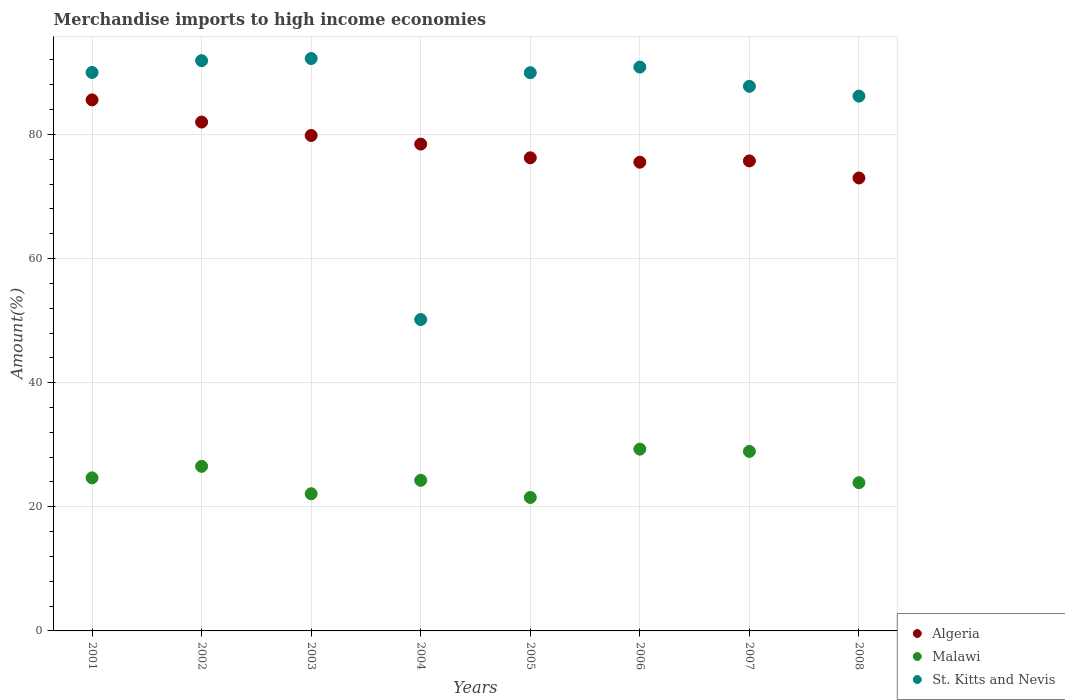Is the number of dotlines equal to the number of legend labels?
Offer a terse response. Yes. What is the percentage of amount earned from merchandise imports in Malawi in 2005?
Keep it short and to the point. 21.5. Across all years, what is the maximum percentage of amount earned from merchandise imports in Algeria?
Offer a terse response. 85.56. Across all years, what is the minimum percentage of amount earned from merchandise imports in Malawi?
Provide a short and direct response. 21.5. In which year was the percentage of amount earned from merchandise imports in Algeria maximum?
Keep it short and to the point. 2001. What is the total percentage of amount earned from merchandise imports in Algeria in the graph?
Your answer should be compact. 626.27. What is the difference between the percentage of amount earned from merchandise imports in Malawi in 2003 and that in 2007?
Your answer should be very brief. -6.82. What is the difference between the percentage of amount earned from merchandise imports in Malawi in 2006 and the percentage of amount earned from merchandise imports in Algeria in 2003?
Keep it short and to the point. -50.54. What is the average percentage of amount earned from merchandise imports in Algeria per year?
Your answer should be very brief. 78.28. In the year 2007, what is the difference between the percentage of amount earned from merchandise imports in Algeria and percentage of amount earned from merchandise imports in St. Kitts and Nevis?
Provide a succinct answer. -12.02. What is the ratio of the percentage of amount earned from merchandise imports in Algeria in 2003 to that in 2006?
Provide a succinct answer. 1.06. Is the percentage of amount earned from merchandise imports in St. Kitts and Nevis in 2006 less than that in 2008?
Your answer should be very brief. No. What is the difference between the highest and the second highest percentage of amount earned from merchandise imports in St. Kitts and Nevis?
Provide a succinct answer. 0.35. What is the difference between the highest and the lowest percentage of amount earned from merchandise imports in Malawi?
Keep it short and to the point. 7.79. In how many years, is the percentage of amount earned from merchandise imports in St. Kitts and Nevis greater than the average percentage of amount earned from merchandise imports in St. Kitts and Nevis taken over all years?
Offer a very short reply. 7. Is the sum of the percentage of amount earned from merchandise imports in St. Kitts and Nevis in 2004 and 2007 greater than the maximum percentage of amount earned from merchandise imports in Malawi across all years?
Make the answer very short. Yes. Is the percentage of amount earned from merchandise imports in Algeria strictly greater than the percentage of amount earned from merchandise imports in Malawi over the years?
Ensure brevity in your answer.  Yes. How many dotlines are there?
Keep it short and to the point. 3. What is the difference between two consecutive major ticks on the Y-axis?
Ensure brevity in your answer.  20. How many legend labels are there?
Provide a succinct answer. 3. How are the legend labels stacked?
Your answer should be very brief. Vertical. What is the title of the graph?
Give a very brief answer. Merchandise imports to high income economies. Does "Bangladesh" appear as one of the legend labels in the graph?
Provide a succinct answer. No. What is the label or title of the Y-axis?
Ensure brevity in your answer.  Amount(%). What is the Amount(%) of Algeria in 2001?
Your response must be concise. 85.56. What is the Amount(%) in Malawi in 2001?
Your answer should be very brief. 24.66. What is the Amount(%) in St. Kitts and Nevis in 2001?
Ensure brevity in your answer.  89.98. What is the Amount(%) of Algeria in 2002?
Your answer should be compact. 81.99. What is the Amount(%) in Malawi in 2002?
Provide a succinct answer. 26.52. What is the Amount(%) of St. Kitts and Nevis in 2002?
Provide a short and direct response. 91.88. What is the Amount(%) in Algeria in 2003?
Keep it short and to the point. 79.83. What is the Amount(%) in Malawi in 2003?
Keep it short and to the point. 22.1. What is the Amount(%) in St. Kitts and Nevis in 2003?
Your response must be concise. 92.23. What is the Amount(%) in Algeria in 2004?
Make the answer very short. 78.44. What is the Amount(%) in Malawi in 2004?
Offer a very short reply. 24.27. What is the Amount(%) in St. Kitts and Nevis in 2004?
Give a very brief answer. 50.17. What is the Amount(%) of Algeria in 2005?
Give a very brief answer. 76.23. What is the Amount(%) in Malawi in 2005?
Offer a very short reply. 21.5. What is the Amount(%) in St. Kitts and Nevis in 2005?
Keep it short and to the point. 89.94. What is the Amount(%) of Algeria in 2006?
Offer a very short reply. 75.52. What is the Amount(%) of Malawi in 2006?
Provide a succinct answer. 29.29. What is the Amount(%) in St. Kitts and Nevis in 2006?
Provide a short and direct response. 90.85. What is the Amount(%) of Algeria in 2007?
Provide a short and direct response. 75.73. What is the Amount(%) in Malawi in 2007?
Your answer should be very brief. 28.93. What is the Amount(%) of St. Kitts and Nevis in 2007?
Keep it short and to the point. 87.75. What is the Amount(%) in Algeria in 2008?
Your response must be concise. 72.98. What is the Amount(%) in Malawi in 2008?
Offer a terse response. 23.88. What is the Amount(%) in St. Kitts and Nevis in 2008?
Make the answer very short. 86.17. Across all years, what is the maximum Amount(%) in Algeria?
Offer a terse response. 85.56. Across all years, what is the maximum Amount(%) in Malawi?
Provide a short and direct response. 29.29. Across all years, what is the maximum Amount(%) in St. Kitts and Nevis?
Provide a short and direct response. 92.23. Across all years, what is the minimum Amount(%) of Algeria?
Your answer should be very brief. 72.98. Across all years, what is the minimum Amount(%) in Malawi?
Ensure brevity in your answer.  21.5. Across all years, what is the minimum Amount(%) in St. Kitts and Nevis?
Ensure brevity in your answer.  50.17. What is the total Amount(%) of Algeria in the graph?
Give a very brief answer. 626.27. What is the total Amount(%) of Malawi in the graph?
Make the answer very short. 201.15. What is the total Amount(%) in St. Kitts and Nevis in the graph?
Your answer should be compact. 678.95. What is the difference between the Amount(%) in Algeria in 2001 and that in 2002?
Give a very brief answer. 3.57. What is the difference between the Amount(%) of Malawi in 2001 and that in 2002?
Provide a short and direct response. -1.86. What is the difference between the Amount(%) of St. Kitts and Nevis in 2001 and that in 2002?
Keep it short and to the point. -1.9. What is the difference between the Amount(%) of Algeria in 2001 and that in 2003?
Your response must be concise. 5.73. What is the difference between the Amount(%) in Malawi in 2001 and that in 2003?
Your answer should be compact. 2.56. What is the difference between the Amount(%) of St. Kitts and Nevis in 2001 and that in 2003?
Provide a short and direct response. -2.25. What is the difference between the Amount(%) of Algeria in 2001 and that in 2004?
Give a very brief answer. 7.12. What is the difference between the Amount(%) in Malawi in 2001 and that in 2004?
Offer a terse response. 0.4. What is the difference between the Amount(%) of St. Kitts and Nevis in 2001 and that in 2004?
Your answer should be compact. 39.81. What is the difference between the Amount(%) of Algeria in 2001 and that in 2005?
Provide a short and direct response. 9.33. What is the difference between the Amount(%) in Malawi in 2001 and that in 2005?
Ensure brevity in your answer.  3.16. What is the difference between the Amount(%) in St. Kitts and Nevis in 2001 and that in 2005?
Offer a terse response. 0.04. What is the difference between the Amount(%) of Algeria in 2001 and that in 2006?
Ensure brevity in your answer.  10.04. What is the difference between the Amount(%) in Malawi in 2001 and that in 2006?
Your response must be concise. -4.63. What is the difference between the Amount(%) in St. Kitts and Nevis in 2001 and that in 2006?
Provide a succinct answer. -0.87. What is the difference between the Amount(%) in Algeria in 2001 and that in 2007?
Give a very brief answer. 9.83. What is the difference between the Amount(%) in Malawi in 2001 and that in 2007?
Provide a succinct answer. -4.27. What is the difference between the Amount(%) in St. Kitts and Nevis in 2001 and that in 2007?
Provide a succinct answer. 2.23. What is the difference between the Amount(%) in Algeria in 2001 and that in 2008?
Ensure brevity in your answer.  12.58. What is the difference between the Amount(%) of Malawi in 2001 and that in 2008?
Make the answer very short. 0.78. What is the difference between the Amount(%) in St. Kitts and Nevis in 2001 and that in 2008?
Make the answer very short. 3.81. What is the difference between the Amount(%) in Algeria in 2002 and that in 2003?
Your answer should be very brief. 2.16. What is the difference between the Amount(%) of Malawi in 2002 and that in 2003?
Your response must be concise. 4.41. What is the difference between the Amount(%) of St. Kitts and Nevis in 2002 and that in 2003?
Offer a terse response. -0.35. What is the difference between the Amount(%) in Algeria in 2002 and that in 2004?
Give a very brief answer. 3.55. What is the difference between the Amount(%) in Malawi in 2002 and that in 2004?
Offer a very short reply. 2.25. What is the difference between the Amount(%) in St. Kitts and Nevis in 2002 and that in 2004?
Keep it short and to the point. 41.71. What is the difference between the Amount(%) in Algeria in 2002 and that in 2005?
Your answer should be compact. 5.76. What is the difference between the Amount(%) in Malawi in 2002 and that in 2005?
Your response must be concise. 5.02. What is the difference between the Amount(%) of St. Kitts and Nevis in 2002 and that in 2005?
Ensure brevity in your answer.  1.94. What is the difference between the Amount(%) of Algeria in 2002 and that in 2006?
Provide a succinct answer. 6.47. What is the difference between the Amount(%) of Malawi in 2002 and that in 2006?
Offer a terse response. -2.77. What is the difference between the Amount(%) of Algeria in 2002 and that in 2007?
Provide a succinct answer. 6.26. What is the difference between the Amount(%) in Malawi in 2002 and that in 2007?
Keep it short and to the point. -2.41. What is the difference between the Amount(%) of St. Kitts and Nevis in 2002 and that in 2007?
Your answer should be very brief. 4.13. What is the difference between the Amount(%) of Algeria in 2002 and that in 2008?
Your answer should be compact. 9.01. What is the difference between the Amount(%) of Malawi in 2002 and that in 2008?
Provide a succinct answer. 2.63. What is the difference between the Amount(%) of St. Kitts and Nevis in 2002 and that in 2008?
Ensure brevity in your answer.  5.71. What is the difference between the Amount(%) in Algeria in 2003 and that in 2004?
Give a very brief answer. 1.39. What is the difference between the Amount(%) in Malawi in 2003 and that in 2004?
Make the answer very short. -2.16. What is the difference between the Amount(%) of St. Kitts and Nevis in 2003 and that in 2004?
Offer a very short reply. 42.06. What is the difference between the Amount(%) in Algeria in 2003 and that in 2005?
Your answer should be very brief. 3.6. What is the difference between the Amount(%) in Malawi in 2003 and that in 2005?
Ensure brevity in your answer.  0.6. What is the difference between the Amount(%) of St. Kitts and Nevis in 2003 and that in 2005?
Provide a succinct answer. 2.29. What is the difference between the Amount(%) in Algeria in 2003 and that in 2006?
Provide a succinct answer. 4.31. What is the difference between the Amount(%) of Malawi in 2003 and that in 2006?
Keep it short and to the point. -7.19. What is the difference between the Amount(%) in St. Kitts and Nevis in 2003 and that in 2006?
Your response must be concise. 1.38. What is the difference between the Amount(%) of Algeria in 2003 and that in 2007?
Provide a succinct answer. 4.1. What is the difference between the Amount(%) in Malawi in 2003 and that in 2007?
Your answer should be very brief. -6.82. What is the difference between the Amount(%) of St. Kitts and Nevis in 2003 and that in 2007?
Offer a terse response. 4.48. What is the difference between the Amount(%) in Algeria in 2003 and that in 2008?
Your answer should be very brief. 6.85. What is the difference between the Amount(%) in Malawi in 2003 and that in 2008?
Provide a succinct answer. -1.78. What is the difference between the Amount(%) in St. Kitts and Nevis in 2003 and that in 2008?
Provide a short and direct response. 6.06. What is the difference between the Amount(%) in Algeria in 2004 and that in 2005?
Provide a succinct answer. 2.21. What is the difference between the Amount(%) of Malawi in 2004 and that in 2005?
Offer a very short reply. 2.77. What is the difference between the Amount(%) of St. Kitts and Nevis in 2004 and that in 2005?
Ensure brevity in your answer.  -39.77. What is the difference between the Amount(%) of Algeria in 2004 and that in 2006?
Your answer should be compact. 2.91. What is the difference between the Amount(%) in Malawi in 2004 and that in 2006?
Your answer should be very brief. -5.02. What is the difference between the Amount(%) in St. Kitts and Nevis in 2004 and that in 2006?
Your answer should be very brief. -40.68. What is the difference between the Amount(%) of Algeria in 2004 and that in 2007?
Your response must be concise. 2.71. What is the difference between the Amount(%) in Malawi in 2004 and that in 2007?
Provide a succinct answer. -4.66. What is the difference between the Amount(%) of St. Kitts and Nevis in 2004 and that in 2007?
Make the answer very short. -37.58. What is the difference between the Amount(%) of Algeria in 2004 and that in 2008?
Your answer should be compact. 5.46. What is the difference between the Amount(%) in Malawi in 2004 and that in 2008?
Offer a terse response. 0.38. What is the difference between the Amount(%) in St. Kitts and Nevis in 2004 and that in 2008?
Ensure brevity in your answer.  -36. What is the difference between the Amount(%) of Algeria in 2005 and that in 2006?
Keep it short and to the point. 0.71. What is the difference between the Amount(%) in Malawi in 2005 and that in 2006?
Provide a short and direct response. -7.79. What is the difference between the Amount(%) of St. Kitts and Nevis in 2005 and that in 2006?
Provide a succinct answer. -0.91. What is the difference between the Amount(%) of Algeria in 2005 and that in 2007?
Offer a very short reply. 0.5. What is the difference between the Amount(%) of Malawi in 2005 and that in 2007?
Your answer should be very brief. -7.43. What is the difference between the Amount(%) in St. Kitts and Nevis in 2005 and that in 2007?
Keep it short and to the point. 2.19. What is the difference between the Amount(%) of Algeria in 2005 and that in 2008?
Your answer should be very brief. 3.25. What is the difference between the Amount(%) of Malawi in 2005 and that in 2008?
Your answer should be very brief. -2.38. What is the difference between the Amount(%) in St. Kitts and Nevis in 2005 and that in 2008?
Ensure brevity in your answer.  3.77. What is the difference between the Amount(%) of Algeria in 2006 and that in 2007?
Offer a terse response. -0.21. What is the difference between the Amount(%) of Malawi in 2006 and that in 2007?
Your response must be concise. 0.36. What is the difference between the Amount(%) of St. Kitts and Nevis in 2006 and that in 2007?
Make the answer very short. 3.1. What is the difference between the Amount(%) in Algeria in 2006 and that in 2008?
Your response must be concise. 2.54. What is the difference between the Amount(%) of Malawi in 2006 and that in 2008?
Give a very brief answer. 5.41. What is the difference between the Amount(%) in St. Kitts and Nevis in 2006 and that in 2008?
Make the answer very short. 4.68. What is the difference between the Amount(%) in Algeria in 2007 and that in 2008?
Keep it short and to the point. 2.75. What is the difference between the Amount(%) of Malawi in 2007 and that in 2008?
Provide a succinct answer. 5.04. What is the difference between the Amount(%) in St. Kitts and Nevis in 2007 and that in 2008?
Give a very brief answer. 1.58. What is the difference between the Amount(%) of Algeria in 2001 and the Amount(%) of Malawi in 2002?
Give a very brief answer. 59.04. What is the difference between the Amount(%) in Algeria in 2001 and the Amount(%) in St. Kitts and Nevis in 2002?
Your answer should be compact. -6.32. What is the difference between the Amount(%) of Malawi in 2001 and the Amount(%) of St. Kitts and Nevis in 2002?
Keep it short and to the point. -67.22. What is the difference between the Amount(%) of Algeria in 2001 and the Amount(%) of Malawi in 2003?
Offer a terse response. 63.46. What is the difference between the Amount(%) in Algeria in 2001 and the Amount(%) in St. Kitts and Nevis in 2003?
Give a very brief answer. -6.66. What is the difference between the Amount(%) of Malawi in 2001 and the Amount(%) of St. Kitts and Nevis in 2003?
Provide a succinct answer. -67.56. What is the difference between the Amount(%) in Algeria in 2001 and the Amount(%) in Malawi in 2004?
Offer a terse response. 61.29. What is the difference between the Amount(%) of Algeria in 2001 and the Amount(%) of St. Kitts and Nevis in 2004?
Provide a short and direct response. 35.39. What is the difference between the Amount(%) of Malawi in 2001 and the Amount(%) of St. Kitts and Nevis in 2004?
Ensure brevity in your answer.  -25.51. What is the difference between the Amount(%) in Algeria in 2001 and the Amount(%) in Malawi in 2005?
Make the answer very short. 64.06. What is the difference between the Amount(%) in Algeria in 2001 and the Amount(%) in St. Kitts and Nevis in 2005?
Your answer should be very brief. -4.38. What is the difference between the Amount(%) of Malawi in 2001 and the Amount(%) of St. Kitts and Nevis in 2005?
Provide a short and direct response. -65.28. What is the difference between the Amount(%) of Algeria in 2001 and the Amount(%) of Malawi in 2006?
Offer a terse response. 56.27. What is the difference between the Amount(%) in Algeria in 2001 and the Amount(%) in St. Kitts and Nevis in 2006?
Offer a terse response. -5.29. What is the difference between the Amount(%) in Malawi in 2001 and the Amount(%) in St. Kitts and Nevis in 2006?
Your answer should be very brief. -66.19. What is the difference between the Amount(%) in Algeria in 2001 and the Amount(%) in Malawi in 2007?
Offer a terse response. 56.63. What is the difference between the Amount(%) of Algeria in 2001 and the Amount(%) of St. Kitts and Nevis in 2007?
Your answer should be very brief. -2.19. What is the difference between the Amount(%) in Malawi in 2001 and the Amount(%) in St. Kitts and Nevis in 2007?
Provide a short and direct response. -63.09. What is the difference between the Amount(%) in Algeria in 2001 and the Amount(%) in Malawi in 2008?
Ensure brevity in your answer.  61.68. What is the difference between the Amount(%) of Algeria in 2001 and the Amount(%) of St. Kitts and Nevis in 2008?
Make the answer very short. -0.61. What is the difference between the Amount(%) of Malawi in 2001 and the Amount(%) of St. Kitts and Nevis in 2008?
Provide a succinct answer. -61.51. What is the difference between the Amount(%) in Algeria in 2002 and the Amount(%) in Malawi in 2003?
Provide a short and direct response. 59.88. What is the difference between the Amount(%) in Algeria in 2002 and the Amount(%) in St. Kitts and Nevis in 2003?
Keep it short and to the point. -10.24. What is the difference between the Amount(%) of Malawi in 2002 and the Amount(%) of St. Kitts and Nevis in 2003?
Give a very brief answer. -65.71. What is the difference between the Amount(%) of Algeria in 2002 and the Amount(%) of Malawi in 2004?
Ensure brevity in your answer.  57.72. What is the difference between the Amount(%) of Algeria in 2002 and the Amount(%) of St. Kitts and Nevis in 2004?
Provide a succinct answer. 31.82. What is the difference between the Amount(%) in Malawi in 2002 and the Amount(%) in St. Kitts and Nevis in 2004?
Your response must be concise. -23.65. What is the difference between the Amount(%) of Algeria in 2002 and the Amount(%) of Malawi in 2005?
Your answer should be very brief. 60.49. What is the difference between the Amount(%) in Algeria in 2002 and the Amount(%) in St. Kitts and Nevis in 2005?
Your answer should be very brief. -7.95. What is the difference between the Amount(%) in Malawi in 2002 and the Amount(%) in St. Kitts and Nevis in 2005?
Offer a terse response. -63.42. What is the difference between the Amount(%) in Algeria in 2002 and the Amount(%) in Malawi in 2006?
Give a very brief answer. 52.7. What is the difference between the Amount(%) in Algeria in 2002 and the Amount(%) in St. Kitts and Nevis in 2006?
Offer a terse response. -8.86. What is the difference between the Amount(%) in Malawi in 2002 and the Amount(%) in St. Kitts and Nevis in 2006?
Give a very brief answer. -64.33. What is the difference between the Amount(%) of Algeria in 2002 and the Amount(%) of Malawi in 2007?
Your response must be concise. 53.06. What is the difference between the Amount(%) in Algeria in 2002 and the Amount(%) in St. Kitts and Nevis in 2007?
Your answer should be very brief. -5.76. What is the difference between the Amount(%) in Malawi in 2002 and the Amount(%) in St. Kitts and Nevis in 2007?
Provide a succinct answer. -61.23. What is the difference between the Amount(%) in Algeria in 2002 and the Amount(%) in Malawi in 2008?
Offer a very short reply. 58.1. What is the difference between the Amount(%) of Algeria in 2002 and the Amount(%) of St. Kitts and Nevis in 2008?
Keep it short and to the point. -4.18. What is the difference between the Amount(%) of Malawi in 2002 and the Amount(%) of St. Kitts and Nevis in 2008?
Give a very brief answer. -59.65. What is the difference between the Amount(%) of Algeria in 2003 and the Amount(%) of Malawi in 2004?
Ensure brevity in your answer.  55.56. What is the difference between the Amount(%) in Algeria in 2003 and the Amount(%) in St. Kitts and Nevis in 2004?
Offer a terse response. 29.66. What is the difference between the Amount(%) in Malawi in 2003 and the Amount(%) in St. Kitts and Nevis in 2004?
Offer a terse response. -28.06. What is the difference between the Amount(%) of Algeria in 2003 and the Amount(%) of Malawi in 2005?
Give a very brief answer. 58.33. What is the difference between the Amount(%) of Algeria in 2003 and the Amount(%) of St. Kitts and Nevis in 2005?
Provide a short and direct response. -10.11. What is the difference between the Amount(%) of Malawi in 2003 and the Amount(%) of St. Kitts and Nevis in 2005?
Make the answer very short. -67.83. What is the difference between the Amount(%) of Algeria in 2003 and the Amount(%) of Malawi in 2006?
Offer a terse response. 50.54. What is the difference between the Amount(%) of Algeria in 2003 and the Amount(%) of St. Kitts and Nevis in 2006?
Your response must be concise. -11.02. What is the difference between the Amount(%) of Malawi in 2003 and the Amount(%) of St. Kitts and Nevis in 2006?
Your response must be concise. -68.74. What is the difference between the Amount(%) of Algeria in 2003 and the Amount(%) of Malawi in 2007?
Your response must be concise. 50.9. What is the difference between the Amount(%) of Algeria in 2003 and the Amount(%) of St. Kitts and Nevis in 2007?
Provide a succinct answer. -7.92. What is the difference between the Amount(%) of Malawi in 2003 and the Amount(%) of St. Kitts and Nevis in 2007?
Your answer should be very brief. -65.65. What is the difference between the Amount(%) in Algeria in 2003 and the Amount(%) in Malawi in 2008?
Offer a terse response. 55.94. What is the difference between the Amount(%) of Algeria in 2003 and the Amount(%) of St. Kitts and Nevis in 2008?
Make the answer very short. -6.34. What is the difference between the Amount(%) in Malawi in 2003 and the Amount(%) in St. Kitts and Nevis in 2008?
Offer a terse response. -64.06. What is the difference between the Amount(%) of Algeria in 2004 and the Amount(%) of Malawi in 2005?
Your answer should be very brief. 56.94. What is the difference between the Amount(%) of Algeria in 2004 and the Amount(%) of St. Kitts and Nevis in 2005?
Provide a short and direct response. -11.5. What is the difference between the Amount(%) in Malawi in 2004 and the Amount(%) in St. Kitts and Nevis in 2005?
Make the answer very short. -65.67. What is the difference between the Amount(%) of Algeria in 2004 and the Amount(%) of Malawi in 2006?
Your response must be concise. 49.15. What is the difference between the Amount(%) in Algeria in 2004 and the Amount(%) in St. Kitts and Nevis in 2006?
Your response must be concise. -12.41. What is the difference between the Amount(%) in Malawi in 2004 and the Amount(%) in St. Kitts and Nevis in 2006?
Offer a very short reply. -66.58. What is the difference between the Amount(%) in Algeria in 2004 and the Amount(%) in Malawi in 2007?
Your answer should be compact. 49.51. What is the difference between the Amount(%) of Algeria in 2004 and the Amount(%) of St. Kitts and Nevis in 2007?
Offer a very short reply. -9.31. What is the difference between the Amount(%) in Malawi in 2004 and the Amount(%) in St. Kitts and Nevis in 2007?
Provide a short and direct response. -63.48. What is the difference between the Amount(%) in Algeria in 2004 and the Amount(%) in Malawi in 2008?
Keep it short and to the point. 54.55. What is the difference between the Amount(%) in Algeria in 2004 and the Amount(%) in St. Kitts and Nevis in 2008?
Provide a short and direct response. -7.73. What is the difference between the Amount(%) of Malawi in 2004 and the Amount(%) of St. Kitts and Nevis in 2008?
Provide a succinct answer. -61.9. What is the difference between the Amount(%) in Algeria in 2005 and the Amount(%) in Malawi in 2006?
Keep it short and to the point. 46.94. What is the difference between the Amount(%) in Algeria in 2005 and the Amount(%) in St. Kitts and Nevis in 2006?
Your answer should be compact. -14.62. What is the difference between the Amount(%) of Malawi in 2005 and the Amount(%) of St. Kitts and Nevis in 2006?
Give a very brief answer. -69.35. What is the difference between the Amount(%) of Algeria in 2005 and the Amount(%) of Malawi in 2007?
Provide a short and direct response. 47.3. What is the difference between the Amount(%) in Algeria in 2005 and the Amount(%) in St. Kitts and Nevis in 2007?
Your response must be concise. -11.52. What is the difference between the Amount(%) of Malawi in 2005 and the Amount(%) of St. Kitts and Nevis in 2007?
Offer a terse response. -66.25. What is the difference between the Amount(%) of Algeria in 2005 and the Amount(%) of Malawi in 2008?
Provide a succinct answer. 52.35. What is the difference between the Amount(%) of Algeria in 2005 and the Amount(%) of St. Kitts and Nevis in 2008?
Provide a succinct answer. -9.94. What is the difference between the Amount(%) in Malawi in 2005 and the Amount(%) in St. Kitts and Nevis in 2008?
Your answer should be compact. -64.67. What is the difference between the Amount(%) of Algeria in 2006 and the Amount(%) of Malawi in 2007?
Make the answer very short. 46.59. What is the difference between the Amount(%) in Algeria in 2006 and the Amount(%) in St. Kitts and Nevis in 2007?
Provide a succinct answer. -12.23. What is the difference between the Amount(%) of Malawi in 2006 and the Amount(%) of St. Kitts and Nevis in 2007?
Your response must be concise. -58.46. What is the difference between the Amount(%) in Algeria in 2006 and the Amount(%) in Malawi in 2008?
Offer a very short reply. 51.64. What is the difference between the Amount(%) in Algeria in 2006 and the Amount(%) in St. Kitts and Nevis in 2008?
Give a very brief answer. -10.65. What is the difference between the Amount(%) of Malawi in 2006 and the Amount(%) of St. Kitts and Nevis in 2008?
Ensure brevity in your answer.  -56.88. What is the difference between the Amount(%) in Algeria in 2007 and the Amount(%) in Malawi in 2008?
Offer a terse response. 51.84. What is the difference between the Amount(%) of Algeria in 2007 and the Amount(%) of St. Kitts and Nevis in 2008?
Your response must be concise. -10.44. What is the difference between the Amount(%) in Malawi in 2007 and the Amount(%) in St. Kitts and Nevis in 2008?
Your answer should be compact. -57.24. What is the average Amount(%) of Algeria per year?
Provide a short and direct response. 78.28. What is the average Amount(%) in Malawi per year?
Ensure brevity in your answer.  25.14. What is the average Amount(%) of St. Kitts and Nevis per year?
Offer a very short reply. 84.87. In the year 2001, what is the difference between the Amount(%) of Algeria and Amount(%) of Malawi?
Make the answer very short. 60.9. In the year 2001, what is the difference between the Amount(%) in Algeria and Amount(%) in St. Kitts and Nevis?
Offer a terse response. -4.42. In the year 2001, what is the difference between the Amount(%) in Malawi and Amount(%) in St. Kitts and Nevis?
Offer a terse response. -65.32. In the year 2002, what is the difference between the Amount(%) in Algeria and Amount(%) in Malawi?
Ensure brevity in your answer.  55.47. In the year 2002, what is the difference between the Amount(%) in Algeria and Amount(%) in St. Kitts and Nevis?
Provide a short and direct response. -9.89. In the year 2002, what is the difference between the Amount(%) of Malawi and Amount(%) of St. Kitts and Nevis?
Your response must be concise. -65.36. In the year 2003, what is the difference between the Amount(%) of Algeria and Amount(%) of Malawi?
Provide a succinct answer. 57.72. In the year 2003, what is the difference between the Amount(%) of Algeria and Amount(%) of St. Kitts and Nevis?
Ensure brevity in your answer.  -12.4. In the year 2003, what is the difference between the Amount(%) of Malawi and Amount(%) of St. Kitts and Nevis?
Your answer should be compact. -70.12. In the year 2004, what is the difference between the Amount(%) of Algeria and Amount(%) of Malawi?
Offer a very short reply. 54.17. In the year 2004, what is the difference between the Amount(%) of Algeria and Amount(%) of St. Kitts and Nevis?
Your answer should be compact. 28.27. In the year 2004, what is the difference between the Amount(%) in Malawi and Amount(%) in St. Kitts and Nevis?
Your answer should be compact. -25.9. In the year 2005, what is the difference between the Amount(%) of Algeria and Amount(%) of Malawi?
Your response must be concise. 54.73. In the year 2005, what is the difference between the Amount(%) of Algeria and Amount(%) of St. Kitts and Nevis?
Make the answer very short. -13.71. In the year 2005, what is the difference between the Amount(%) in Malawi and Amount(%) in St. Kitts and Nevis?
Ensure brevity in your answer.  -68.44. In the year 2006, what is the difference between the Amount(%) in Algeria and Amount(%) in Malawi?
Offer a very short reply. 46.23. In the year 2006, what is the difference between the Amount(%) of Algeria and Amount(%) of St. Kitts and Nevis?
Give a very brief answer. -15.33. In the year 2006, what is the difference between the Amount(%) in Malawi and Amount(%) in St. Kitts and Nevis?
Provide a short and direct response. -61.56. In the year 2007, what is the difference between the Amount(%) in Algeria and Amount(%) in Malawi?
Your response must be concise. 46.8. In the year 2007, what is the difference between the Amount(%) in Algeria and Amount(%) in St. Kitts and Nevis?
Offer a terse response. -12.02. In the year 2007, what is the difference between the Amount(%) in Malawi and Amount(%) in St. Kitts and Nevis?
Your answer should be very brief. -58.82. In the year 2008, what is the difference between the Amount(%) in Algeria and Amount(%) in Malawi?
Make the answer very short. 49.09. In the year 2008, what is the difference between the Amount(%) in Algeria and Amount(%) in St. Kitts and Nevis?
Keep it short and to the point. -13.19. In the year 2008, what is the difference between the Amount(%) in Malawi and Amount(%) in St. Kitts and Nevis?
Keep it short and to the point. -62.28. What is the ratio of the Amount(%) of Algeria in 2001 to that in 2002?
Your answer should be compact. 1.04. What is the ratio of the Amount(%) in St. Kitts and Nevis in 2001 to that in 2002?
Offer a terse response. 0.98. What is the ratio of the Amount(%) of Algeria in 2001 to that in 2003?
Offer a very short reply. 1.07. What is the ratio of the Amount(%) of Malawi in 2001 to that in 2003?
Keep it short and to the point. 1.12. What is the ratio of the Amount(%) of St. Kitts and Nevis in 2001 to that in 2003?
Your response must be concise. 0.98. What is the ratio of the Amount(%) of Algeria in 2001 to that in 2004?
Your answer should be compact. 1.09. What is the ratio of the Amount(%) in Malawi in 2001 to that in 2004?
Keep it short and to the point. 1.02. What is the ratio of the Amount(%) of St. Kitts and Nevis in 2001 to that in 2004?
Provide a short and direct response. 1.79. What is the ratio of the Amount(%) in Algeria in 2001 to that in 2005?
Provide a short and direct response. 1.12. What is the ratio of the Amount(%) in Malawi in 2001 to that in 2005?
Provide a succinct answer. 1.15. What is the ratio of the Amount(%) of Algeria in 2001 to that in 2006?
Provide a succinct answer. 1.13. What is the ratio of the Amount(%) in Malawi in 2001 to that in 2006?
Your answer should be very brief. 0.84. What is the ratio of the Amount(%) of St. Kitts and Nevis in 2001 to that in 2006?
Make the answer very short. 0.99. What is the ratio of the Amount(%) of Algeria in 2001 to that in 2007?
Provide a short and direct response. 1.13. What is the ratio of the Amount(%) in Malawi in 2001 to that in 2007?
Your answer should be compact. 0.85. What is the ratio of the Amount(%) in St. Kitts and Nevis in 2001 to that in 2007?
Offer a very short reply. 1.03. What is the ratio of the Amount(%) in Algeria in 2001 to that in 2008?
Ensure brevity in your answer.  1.17. What is the ratio of the Amount(%) in Malawi in 2001 to that in 2008?
Provide a short and direct response. 1.03. What is the ratio of the Amount(%) in St. Kitts and Nevis in 2001 to that in 2008?
Offer a very short reply. 1.04. What is the ratio of the Amount(%) in Algeria in 2002 to that in 2003?
Provide a succinct answer. 1.03. What is the ratio of the Amount(%) in Malawi in 2002 to that in 2003?
Provide a succinct answer. 1.2. What is the ratio of the Amount(%) in Algeria in 2002 to that in 2004?
Your answer should be compact. 1.05. What is the ratio of the Amount(%) in Malawi in 2002 to that in 2004?
Offer a terse response. 1.09. What is the ratio of the Amount(%) in St. Kitts and Nevis in 2002 to that in 2004?
Ensure brevity in your answer.  1.83. What is the ratio of the Amount(%) of Algeria in 2002 to that in 2005?
Provide a short and direct response. 1.08. What is the ratio of the Amount(%) of Malawi in 2002 to that in 2005?
Your answer should be compact. 1.23. What is the ratio of the Amount(%) in St. Kitts and Nevis in 2002 to that in 2005?
Offer a terse response. 1.02. What is the ratio of the Amount(%) in Algeria in 2002 to that in 2006?
Keep it short and to the point. 1.09. What is the ratio of the Amount(%) of Malawi in 2002 to that in 2006?
Your answer should be compact. 0.91. What is the ratio of the Amount(%) in St. Kitts and Nevis in 2002 to that in 2006?
Your response must be concise. 1.01. What is the ratio of the Amount(%) in Algeria in 2002 to that in 2007?
Provide a short and direct response. 1.08. What is the ratio of the Amount(%) of St. Kitts and Nevis in 2002 to that in 2007?
Your answer should be compact. 1.05. What is the ratio of the Amount(%) of Algeria in 2002 to that in 2008?
Give a very brief answer. 1.12. What is the ratio of the Amount(%) in Malawi in 2002 to that in 2008?
Offer a very short reply. 1.11. What is the ratio of the Amount(%) of St. Kitts and Nevis in 2002 to that in 2008?
Your response must be concise. 1.07. What is the ratio of the Amount(%) in Algeria in 2003 to that in 2004?
Keep it short and to the point. 1.02. What is the ratio of the Amount(%) in Malawi in 2003 to that in 2004?
Make the answer very short. 0.91. What is the ratio of the Amount(%) in St. Kitts and Nevis in 2003 to that in 2004?
Your response must be concise. 1.84. What is the ratio of the Amount(%) of Algeria in 2003 to that in 2005?
Your answer should be compact. 1.05. What is the ratio of the Amount(%) of Malawi in 2003 to that in 2005?
Provide a succinct answer. 1.03. What is the ratio of the Amount(%) of St. Kitts and Nevis in 2003 to that in 2005?
Ensure brevity in your answer.  1.03. What is the ratio of the Amount(%) in Algeria in 2003 to that in 2006?
Make the answer very short. 1.06. What is the ratio of the Amount(%) of Malawi in 2003 to that in 2006?
Provide a short and direct response. 0.75. What is the ratio of the Amount(%) of St. Kitts and Nevis in 2003 to that in 2006?
Your response must be concise. 1.02. What is the ratio of the Amount(%) of Algeria in 2003 to that in 2007?
Your answer should be compact. 1.05. What is the ratio of the Amount(%) of Malawi in 2003 to that in 2007?
Provide a succinct answer. 0.76. What is the ratio of the Amount(%) of St. Kitts and Nevis in 2003 to that in 2007?
Provide a short and direct response. 1.05. What is the ratio of the Amount(%) of Algeria in 2003 to that in 2008?
Provide a short and direct response. 1.09. What is the ratio of the Amount(%) in Malawi in 2003 to that in 2008?
Provide a short and direct response. 0.93. What is the ratio of the Amount(%) of St. Kitts and Nevis in 2003 to that in 2008?
Your response must be concise. 1.07. What is the ratio of the Amount(%) of Algeria in 2004 to that in 2005?
Your response must be concise. 1.03. What is the ratio of the Amount(%) of Malawi in 2004 to that in 2005?
Your response must be concise. 1.13. What is the ratio of the Amount(%) of St. Kitts and Nevis in 2004 to that in 2005?
Your response must be concise. 0.56. What is the ratio of the Amount(%) in Algeria in 2004 to that in 2006?
Provide a short and direct response. 1.04. What is the ratio of the Amount(%) in Malawi in 2004 to that in 2006?
Provide a succinct answer. 0.83. What is the ratio of the Amount(%) of St. Kitts and Nevis in 2004 to that in 2006?
Keep it short and to the point. 0.55. What is the ratio of the Amount(%) of Algeria in 2004 to that in 2007?
Make the answer very short. 1.04. What is the ratio of the Amount(%) in Malawi in 2004 to that in 2007?
Your answer should be very brief. 0.84. What is the ratio of the Amount(%) of St. Kitts and Nevis in 2004 to that in 2007?
Provide a short and direct response. 0.57. What is the ratio of the Amount(%) of Algeria in 2004 to that in 2008?
Your response must be concise. 1.07. What is the ratio of the Amount(%) in St. Kitts and Nevis in 2004 to that in 2008?
Provide a succinct answer. 0.58. What is the ratio of the Amount(%) in Algeria in 2005 to that in 2006?
Make the answer very short. 1.01. What is the ratio of the Amount(%) of Malawi in 2005 to that in 2006?
Give a very brief answer. 0.73. What is the ratio of the Amount(%) in St. Kitts and Nevis in 2005 to that in 2006?
Offer a very short reply. 0.99. What is the ratio of the Amount(%) in Algeria in 2005 to that in 2007?
Keep it short and to the point. 1.01. What is the ratio of the Amount(%) of Malawi in 2005 to that in 2007?
Ensure brevity in your answer.  0.74. What is the ratio of the Amount(%) in St. Kitts and Nevis in 2005 to that in 2007?
Give a very brief answer. 1.02. What is the ratio of the Amount(%) in Algeria in 2005 to that in 2008?
Provide a short and direct response. 1.04. What is the ratio of the Amount(%) of Malawi in 2005 to that in 2008?
Make the answer very short. 0.9. What is the ratio of the Amount(%) in St. Kitts and Nevis in 2005 to that in 2008?
Keep it short and to the point. 1.04. What is the ratio of the Amount(%) in Malawi in 2006 to that in 2007?
Your answer should be compact. 1.01. What is the ratio of the Amount(%) of St. Kitts and Nevis in 2006 to that in 2007?
Give a very brief answer. 1.04. What is the ratio of the Amount(%) in Algeria in 2006 to that in 2008?
Ensure brevity in your answer.  1.03. What is the ratio of the Amount(%) in Malawi in 2006 to that in 2008?
Provide a succinct answer. 1.23. What is the ratio of the Amount(%) of St. Kitts and Nevis in 2006 to that in 2008?
Provide a short and direct response. 1.05. What is the ratio of the Amount(%) in Algeria in 2007 to that in 2008?
Provide a succinct answer. 1.04. What is the ratio of the Amount(%) in Malawi in 2007 to that in 2008?
Your answer should be compact. 1.21. What is the ratio of the Amount(%) in St. Kitts and Nevis in 2007 to that in 2008?
Give a very brief answer. 1.02. What is the difference between the highest and the second highest Amount(%) in Algeria?
Ensure brevity in your answer.  3.57. What is the difference between the highest and the second highest Amount(%) in Malawi?
Give a very brief answer. 0.36. What is the difference between the highest and the second highest Amount(%) of St. Kitts and Nevis?
Ensure brevity in your answer.  0.35. What is the difference between the highest and the lowest Amount(%) of Algeria?
Make the answer very short. 12.58. What is the difference between the highest and the lowest Amount(%) in Malawi?
Offer a very short reply. 7.79. What is the difference between the highest and the lowest Amount(%) in St. Kitts and Nevis?
Offer a terse response. 42.06. 